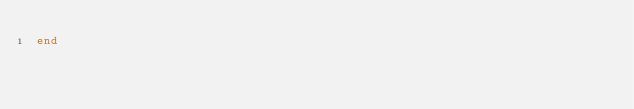Convert code to text. <code><loc_0><loc_0><loc_500><loc_500><_Ruby_>end
</code> 